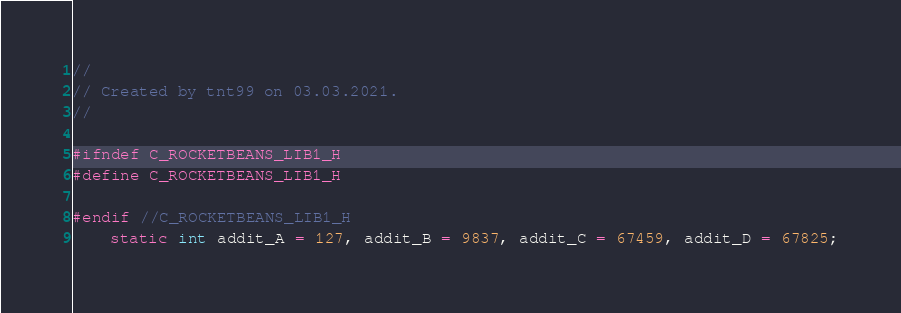Convert code to text. <code><loc_0><loc_0><loc_500><loc_500><_C_>//
// Created by tnt99 on 03.03.2021.
//

#ifndef C_ROCKETBEANS_LIB1_H
#define C_ROCKETBEANS_LIB1_H

#endif //C_ROCKETBEANS_LIB1_H
    static int addit_A = 127, addit_B = 9837, addit_C = 67459, addit_D = 67825;
</code> 